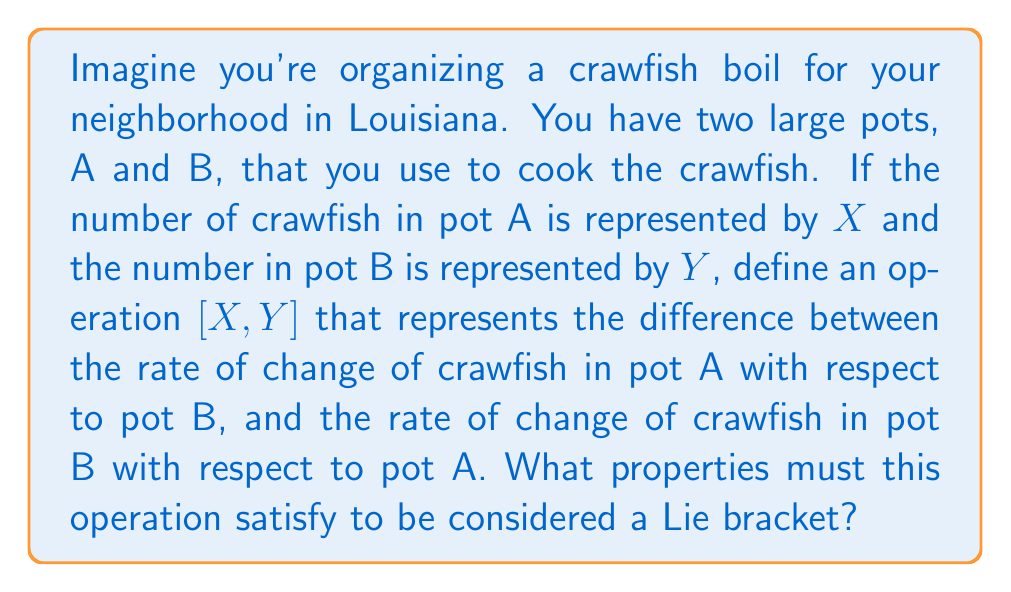Give your solution to this math problem. Let's break this down step-by-step:

1) First, we need to understand what a Lie bracket is in mathematical terms. The Lie bracket is a binary operation that satisfies certain properties. In our crawfish analogy, $[X,Y]$ represents this operation.

2) The Lie bracket must satisfy the following properties:

   a) Bilinearity: 
      $[aX + bY, Z] = a[X,Z] + b[Y,Z]$
      $[X, aY + bZ] = a[X,Y] + b[X,Z]$
      where $a$ and $b$ are scalars.

   b) Antisymmetry: 
      $[X,Y] = -[Y,X]$

   c) Jacobi identity:
      $[X,[Y,Z]] + [Y,[Z,X]] + [Z,[X,Y]] = 0$

3) In our crawfish context:
   - Bilinearity means that if we change the number of crawfish in one pot, the operation behaves linearly.
   - Antisymmetry implies that swapping the order of the pots in our operation negates the result.
   - The Jacobi identity is a bit more abstract, but it ensures a certain consistency when we apply the operation multiple times.

4) These properties ensure that our operation $[X,Y]$ behaves in a way that's consistent with the mathematical definition of a Lie bracket.

5) It's worth noting that while this crawfish analogy helps us visualize the concept, real Lie brackets are typically defined on vector spaces and have important applications in physics and differential geometry.
Answer: To be considered a Lie bracket, the operation $[X,Y]$ must satisfy these three properties:

1) Bilinearity: $[aX + bY, Z] = a[X,Z] + b[Y,Z]$ and $[X, aY + bZ] = a[X,Y] + b[X,Z]$
2) Antisymmetry: $[X,Y] = -[Y,X]$
3) Jacobi identity: $[X,[Y,Z]] + [Y,[Z,X]] + [Z,[X,Y]] = 0$ 